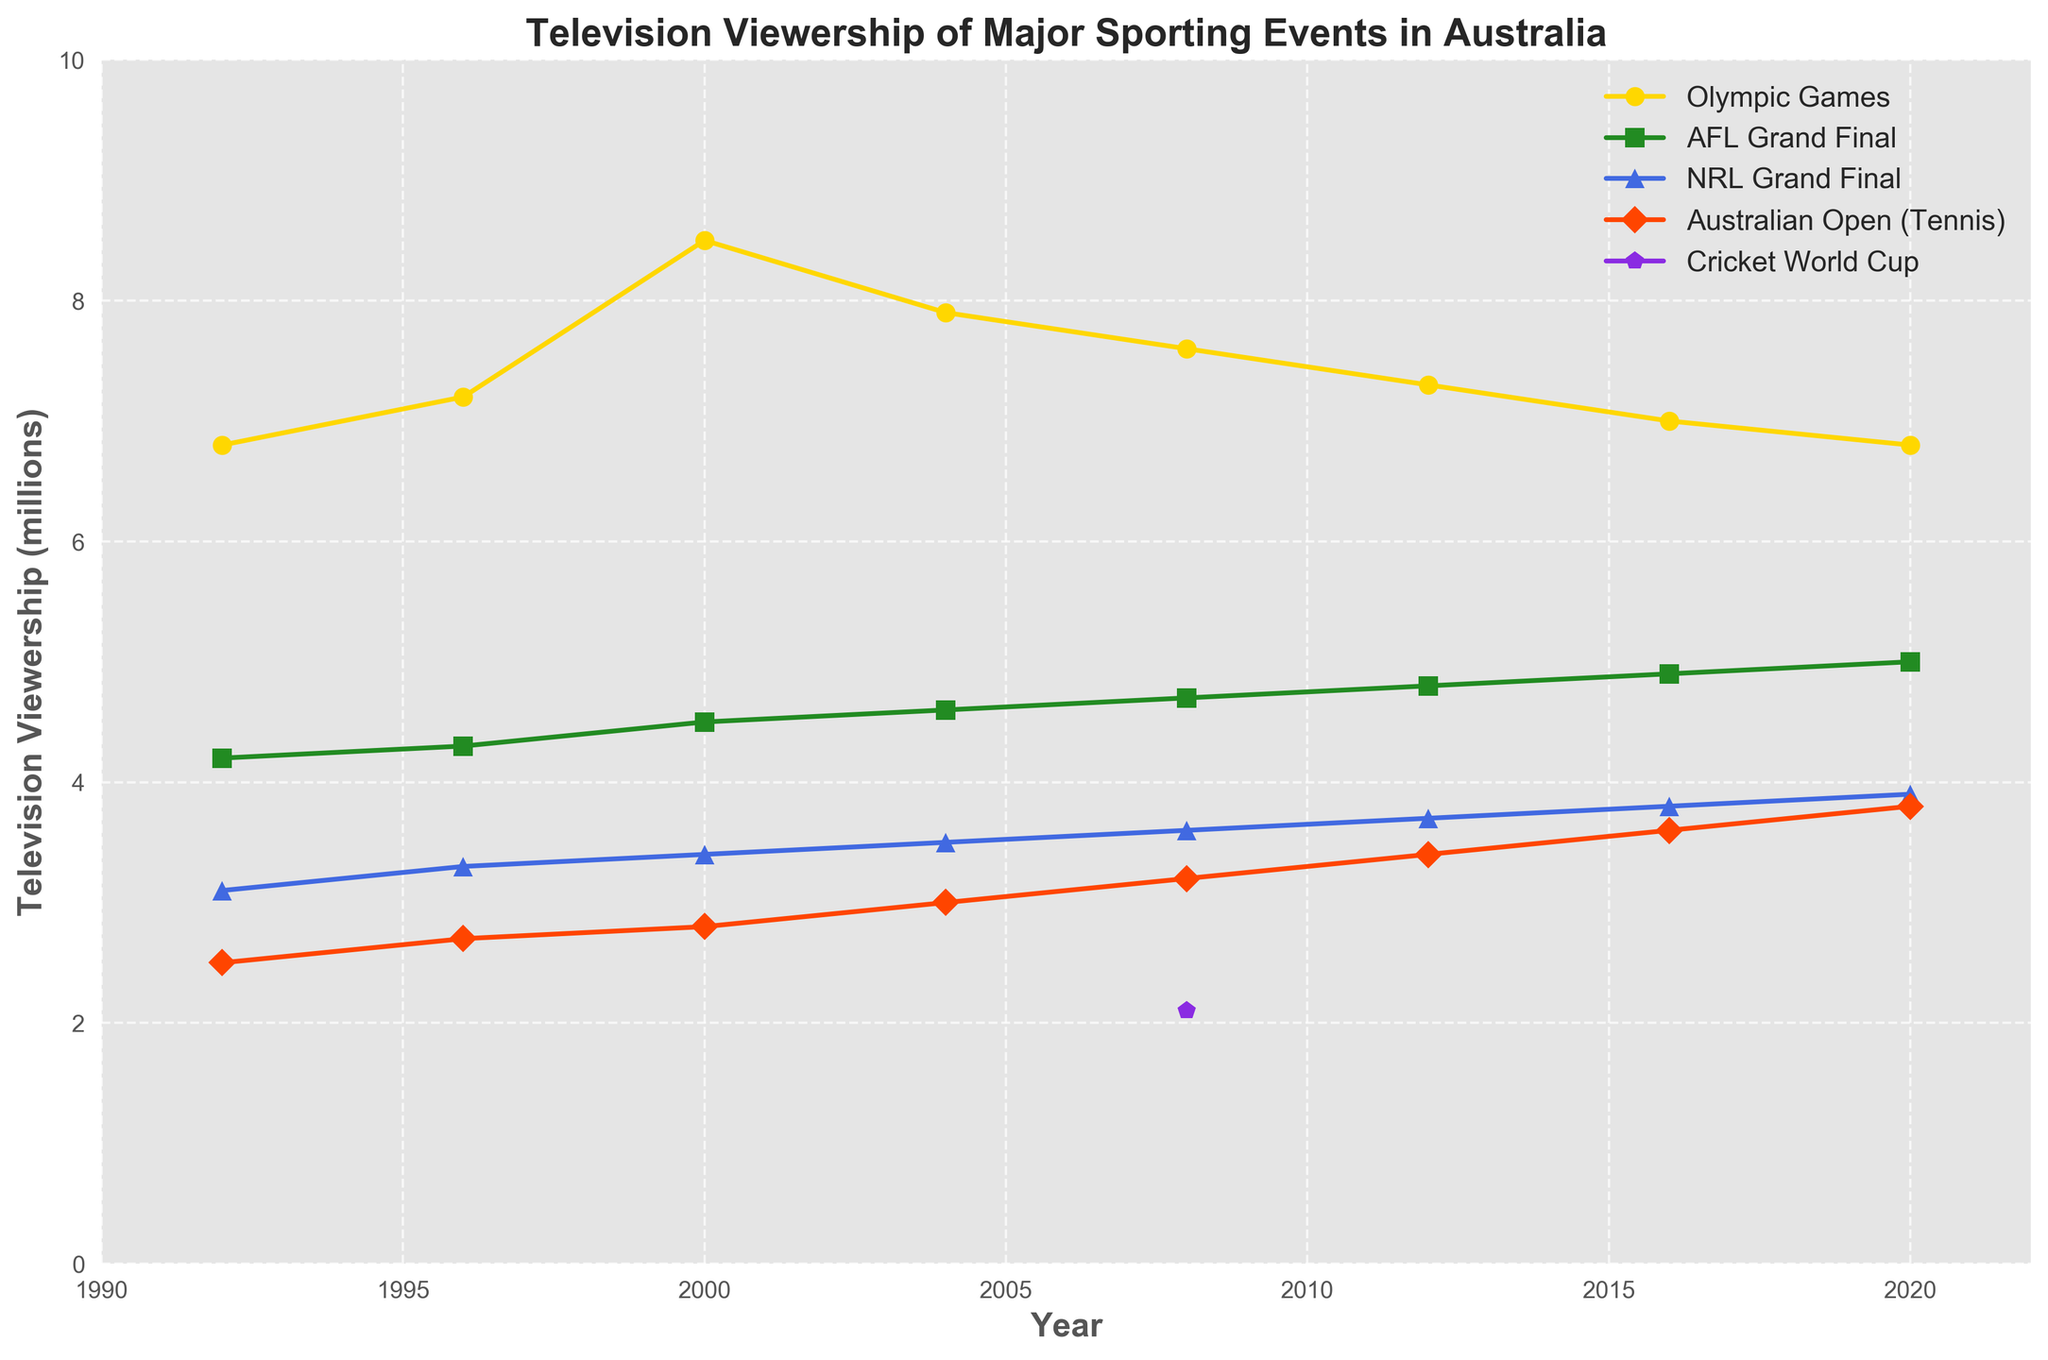How has the viewership of the Olympic Games changed from 1992 to 2020? To find the change, look at the starting value in 1992 and see how it changes in 2020. In 1992, the viewership was 6.8 million, and in 2020 it was also 6.8 million. So, the viewership started and ended at the same value over the given period.
Answer: It remained the same Which event had the highest viewership in any given year, and what year was it? To identify the highest viewership, compare all the viewership values across all the years for every event. The Olympics in the year 2000 had a viewership of 8.5 million, which is the highest among all.
Answer: Olympic Games in 2000 What was the average viewership of the AFL Grand Final across the given years? Add up the AFL Grand Final viewership numbers (4.2, 4.3, 4.5, 4.6, 4.7, 4.8, 4.9, 5.0) and divide by the number of years (8). The total is 37.0 and the average is 37.0 / 8.
Answer: 4.625 million Between which consecutive years did the NRL Grand Final see the biggest increase in viewership? Compare the differences in viewership from one year to the next for the NRL Grand Final. The biggest increase is from 2016 to 2020, where viewership increased from 3.8 to 3.9 million.
Answer: 2016 to 2020 In which year did the Australian Open (Tennis) first surpass a viewership of 3.0 million? Look at the viewership numbers for the Australian Open (Tennis) and find the first year it exceeded 3.0 million. In 2004, the viewership was 3.0 million, and it exceeded 3.0 million in 2008 with 3.2 million.
Answer: 2008 Which event showed a declining trend in viewership from 2000 to 2020? Check the viewership trend for each event individually over the period from 2000 to 2020. The Olympic Games viewership decreased from 8.5 million to 6.8 million, indicating a decline.
Answer: Olympic Games By how much did the viewership of the AFL Grand Final increase from 2000 to 2020? Subtract the viewership figure of the AFL Grand Final in 2000 (4.5 million) from its viewership in 2020 (5.0 million), which gives an increase of 0.5 million.
Answer: 0.5 million Which event consistently increased its viewership every four years from 1992 to 2020? Identify the event that has increasing viewership values for every recorded year. The AFL Grand Final viewership consistently increased from 4.2 million in 1992 to 5.0 million in 2020.
Answer: AFL Grand Final What is the total cumulative viewership for the Cricket World Cup and how many years is it recorded? Sum the viewership values of the Cricket World Cup and identify the number of years with recorded data. The viewership is recorded only once with 2.1 million in 2008.
Answer: 2.1 million, 1 year 